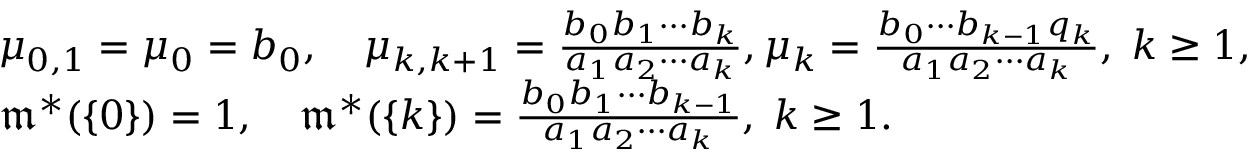<formula> <loc_0><loc_0><loc_500><loc_500>\begin{array} { r l } & { \mu _ { 0 , 1 } = \mu _ { 0 } = b _ { 0 } , \quad \mu _ { k , k + 1 } = \frac { b _ { 0 } b _ { 1 } \cdots b _ { k } } { a _ { 1 } a _ { 2 } \cdots a _ { k } } , \mu _ { k } = \frac { b _ { 0 } \cdots b _ { k - 1 } q _ { k } } { a _ { 1 } a _ { 2 } \cdots a _ { k } } , \, k \geq 1 , } \\ & { \mathfrak { m } ^ { * } ( \{ 0 \} ) = 1 , \quad \mathfrak { m } ^ { * } ( \{ k \} ) = \frac { b _ { 0 } b _ { 1 } \cdots b _ { k - 1 } } { a _ { 1 } a _ { 2 } \cdots a _ { k } } , \, k \geq 1 . } \end{array}</formula> 